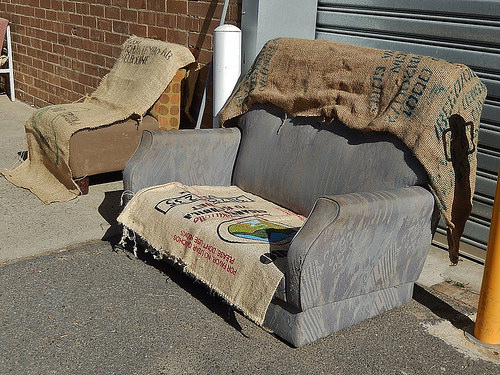<image>
Is there a trash on the sofa? Yes. Looking at the image, I can see the trash is positioned on top of the sofa, with the sofa providing support. Is there a blanket on the ground? No. The blanket is not positioned on the ground. They may be near each other, but the blanket is not supported by or resting on top of the ground. 